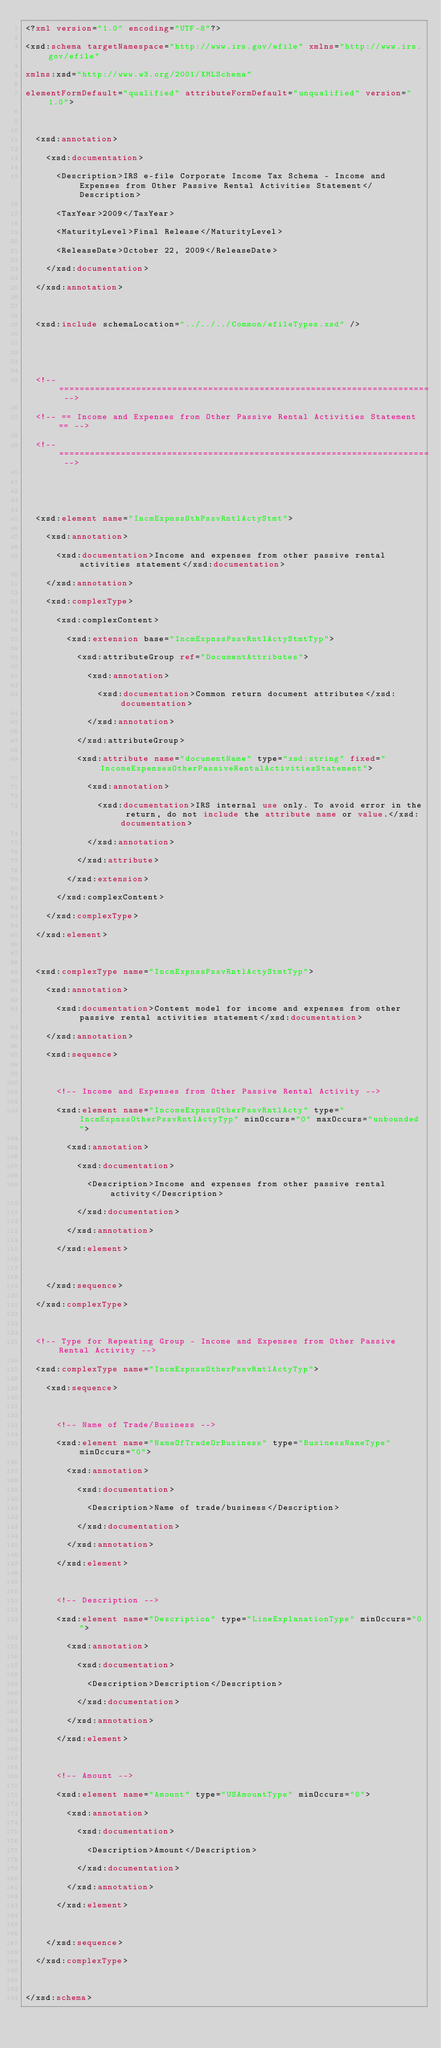Convert code to text. <code><loc_0><loc_0><loc_500><loc_500><_XML_><?xml version="1.0" encoding="UTF-8"?>
<xsd:schema targetNamespace="http://www.irs.gov/efile" xmlns="http://www.irs.gov/efile" 
xmlns:xsd="http://www.w3.org/2001/XMLSchema" 
elementFormDefault="qualified" attributeFormDefault="unqualified" version="1.0">

	<xsd:annotation>
		<xsd:documentation>
			<Description>IRS e-file Corporate Income Tax Schema - Income and Expenses from Other Passive Rental Activities Statement</Description>
			<TaxYear>2009</TaxYear>
			<MaturityLevel>Final Release</MaturityLevel>
			<ReleaseDate>October 22, 2009</ReleaseDate>
		</xsd:documentation>
	</xsd:annotation>

	<xsd:include schemaLocation="../../../Common/efileTypes.xsd" />


	<!-- ======================================================================== -->
	<!-- == Income and Expenses from Other Passive Rental Activities Statement == -->
	<!-- ======================================================================== -->


	<xsd:element name="IncmExpnssOthPssvRntlActyStmt">
		<xsd:annotation>
			<xsd:documentation>Income and expenses from other passive rental activities statement</xsd:documentation>
		</xsd:annotation>
		<xsd:complexType>
			<xsd:complexContent>
				<xsd:extension base="IncmExpnssPssvRntlActyStmtTyp">
					<xsd:attributeGroup ref="DocumentAttributes">
						<xsd:annotation>
							<xsd:documentation>Common return document attributes</xsd:documentation>
						</xsd:annotation>
					</xsd:attributeGroup>
					<xsd:attribute name="documentName" type="xsd:string" fixed="IncomeExpensesOtherPassiveRentalActivitiesStatement">
						<xsd:annotation>
							<xsd:documentation>IRS internal use only. To avoid error in the return, do not include the attribute name or value.</xsd:documentation>
						</xsd:annotation>
					</xsd:attribute>
				</xsd:extension>
			</xsd:complexContent>
		</xsd:complexType>
	</xsd:element>	
	
	<xsd:complexType name="IncmExpnssPssvRntlActyStmtTyp">
		<xsd:annotation>
			<xsd:documentation>Content model for income and expenses from other passive rental activities statement</xsd:documentation>
		</xsd:annotation>
		<xsd:sequence>		
				
			<!-- Income and Expenses from Other Passive Rental Activity -->
			<xsd:element name="IncomeExpnssOtherPssvRntlActy" type="IncmExpnssOtherPssvRntlActyTyp" minOccurs="0" maxOccurs="unbounded">	
				<xsd:annotation>
					<xsd:documentation>
						<Description>Income and expenses from other passive rental activity</Description>
					</xsd:documentation>
				</xsd:annotation>
			</xsd:element>
			
		</xsd:sequence>
	</xsd:complexType>		

	<!-- Type for Repeating Group - Income and Expenses from Other Passive Rental Activity -->
	<xsd:complexType name="IncmExpnssOtherPssvRntlActyTyp">
		<xsd:sequence>		
	
			<!-- Name of Trade/Business -->
			<xsd:element name="NameOfTradeOrBusiness" type="BusinessNameType" minOccurs="0">
				<xsd:annotation>
					<xsd:documentation>
						<Description>Name of trade/business</Description>
					</xsd:documentation>
				</xsd:annotation>
			</xsd:element>

			<!-- Description -->
			<xsd:element name="Description" type="LineExplanationType" minOccurs="0">
				<xsd:annotation>
					<xsd:documentation>
						<Description>Description</Description>
					</xsd:documentation>
				</xsd:annotation>
			</xsd:element>			
			
			<!-- Amount -->
			<xsd:element name="Amount" type="USAmountType" minOccurs="0">
				<xsd:annotation>
					<xsd:documentation>
						<Description>Amount</Description>
					</xsd:documentation>
				</xsd:annotation>
			</xsd:element>				
						
		</xsd:sequence>
	</xsd:complexType>	
	
</xsd:schema>
</code> 